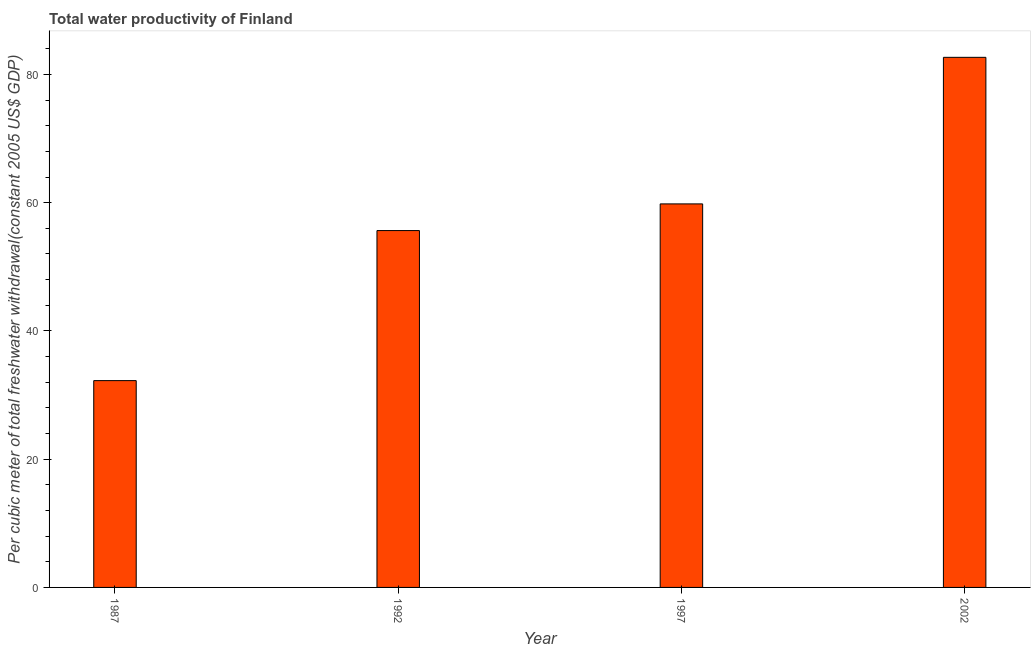What is the title of the graph?
Keep it short and to the point. Total water productivity of Finland. What is the label or title of the Y-axis?
Give a very brief answer. Per cubic meter of total freshwater withdrawal(constant 2005 US$ GDP). What is the total water productivity in 2002?
Your response must be concise. 82.67. Across all years, what is the maximum total water productivity?
Provide a succinct answer. 82.67. Across all years, what is the minimum total water productivity?
Provide a succinct answer. 32.25. In which year was the total water productivity maximum?
Provide a short and direct response. 2002. In which year was the total water productivity minimum?
Offer a very short reply. 1987. What is the sum of the total water productivity?
Keep it short and to the point. 230.38. What is the difference between the total water productivity in 1987 and 1997?
Give a very brief answer. -27.56. What is the average total water productivity per year?
Ensure brevity in your answer.  57.59. What is the median total water productivity?
Your response must be concise. 57.73. In how many years, is the total water productivity greater than 80 US$?
Provide a short and direct response. 1. Is the total water productivity in 1987 less than that in 1992?
Your response must be concise. Yes. What is the difference between the highest and the second highest total water productivity?
Keep it short and to the point. 22.86. What is the difference between the highest and the lowest total water productivity?
Ensure brevity in your answer.  50.41. In how many years, is the total water productivity greater than the average total water productivity taken over all years?
Ensure brevity in your answer.  2. How many years are there in the graph?
Make the answer very short. 4. What is the Per cubic meter of total freshwater withdrawal(constant 2005 US$ GDP) of 1987?
Provide a short and direct response. 32.25. What is the Per cubic meter of total freshwater withdrawal(constant 2005 US$ GDP) in 1992?
Offer a terse response. 55.65. What is the Per cubic meter of total freshwater withdrawal(constant 2005 US$ GDP) of 1997?
Offer a terse response. 59.81. What is the Per cubic meter of total freshwater withdrawal(constant 2005 US$ GDP) in 2002?
Your response must be concise. 82.67. What is the difference between the Per cubic meter of total freshwater withdrawal(constant 2005 US$ GDP) in 1987 and 1992?
Your response must be concise. -23.4. What is the difference between the Per cubic meter of total freshwater withdrawal(constant 2005 US$ GDP) in 1987 and 1997?
Your response must be concise. -27.56. What is the difference between the Per cubic meter of total freshwater withdrawal(constant 2005 US$ GDP) in 1987 and 2002?
Offer a very short reply. -50.41. What is the difference between the Per cubic meter of total freshwater withdrawal(constant 2005 US$ GDP) in 1992 and 1997?
Keep it short and to the point. -4.16. What is the difference between the Per cubic meter of total freshwater withdrawal(constant 2005 US$ GDP) in 1992 and 2002?
Ensure brevity in your answer.  -27.02. What is the difference between the Per cubic meter of total freshwater withdrawal(constant 2005 US$ GDP) in 1997 and 2002?
Make the answer very short. -22.86. What is the ratio of the Per cubic meter of total freshwater withdrawal(constant 2005 US$ GDP) in 1987 to that in 1992?
Provide a succinct answer. 0.58. What is the ratio of the Per cubic meter of total freshwater withdrawal(constant 2005 US$ GDP) in 1987 to that in 1997?
Your answer should be compact. 0.54. What is the ratio of the Per cubic meter of total freshwater withdrawal(constant 2005 US$ GDP) in 1987 to that in 2002?
Make the answer very short. 0.39. What is the ratio of the Per cubic meter of total freshwater withdrawal(constant 2005 US$ GDP) in 1992 to that in 2002?
Make the answer very short. 0.67. What is the ratio of the Per cubic meter of total freshwater withdrawal(constant 2005 US$ GDP) in 1997 to that in 2002?
Keep it short and to the point. 0.72. 